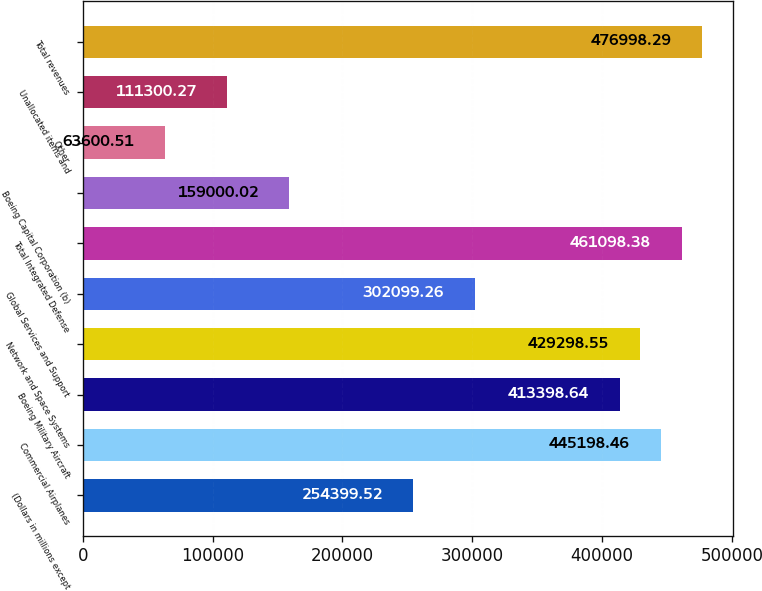Convert chart to OTSL. <chart><loc_0><loc_0><loc_500><loc_500><bar_chart><fcel>(Dollars in millions except<fcel>Commercial Airplanes<fcel>Boeing Military Aircraft<fcel>Network and Space Systems<fcel>Global Services and Support<fcel>Total Integrated Defense<fcel>Boeing Capital Corporation (b)<fcel>Other<fcel>Unallocated items and<fcel>Total revenues<nl><fcel>254400<fcel>445198<fcel>413399<fcel>429299<fcel>302099<fcel>461098<fcel>159000<fcel>63600.5<fcel>111300<fcel>476998<nl></chart> 